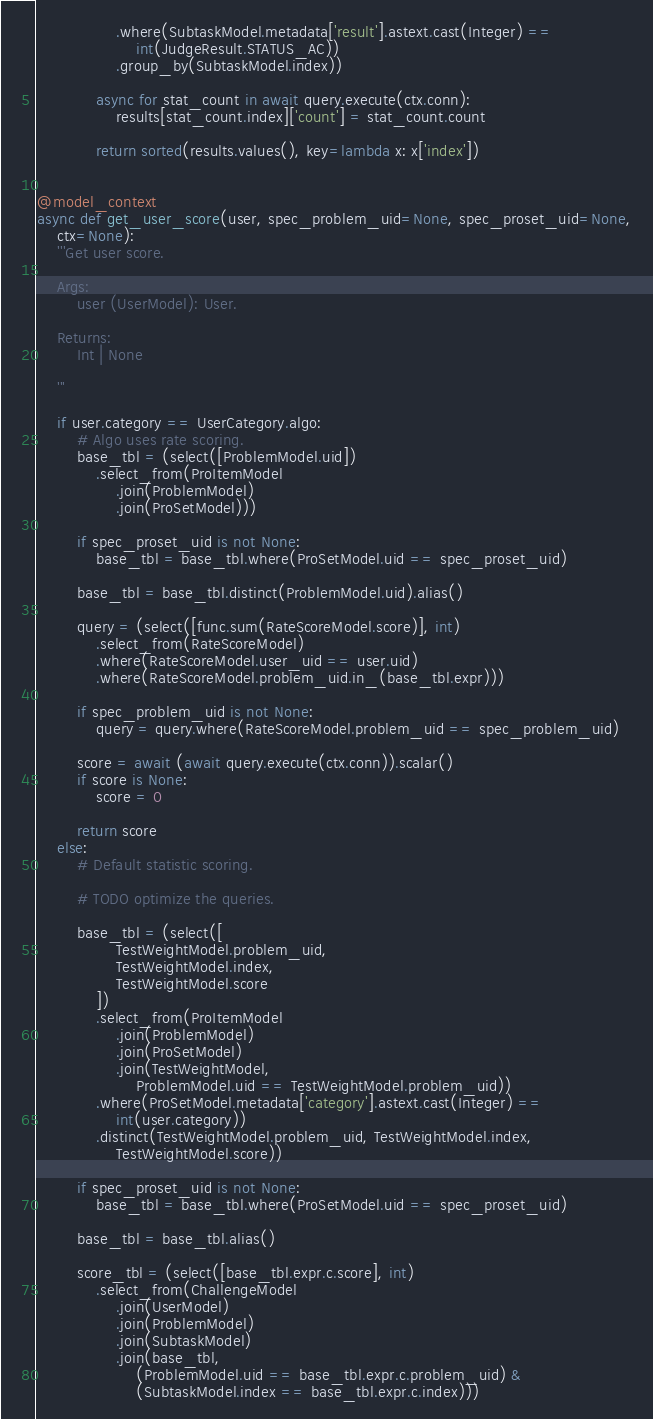Convert code to text. <code><loc_0><loc_0><loc_500><loc_500><_Python_>                .where(SubtaskModel.metadata['result'].astext.cast(Integer) ==
                    int(JudgeResult.STATUS_AC))
                .group_by(SubtaskModel.index))

            async for stat_count in await query.execute(ctx.conn):
                results[stat_count.index]['count'] = stat_count.count

            return sorted(results.values(), key=lambda x: x['index'])


@model_context
async def get_user_score(user, spec_problem_uid=None, spec_proset_uid=None,
    ctx=None):
    '''Get user score.

    Args:
        user (UserModel): User.

    Returns:
        Int | None

    '''

    if user.category == UserCategory.algo:
        # Algo uses rate scoring.
        base_tbl = (select([ProblemModel.uid])
            .select_from(ProItemModel
                .join(ProblemModel)
                .join(ProSetModel)))

        if spec_proset_uid is not None:
            base_tbl = base_tbl.where(ProSetModel.uid == spec_proset_uid)

        base_tbl = base_tbl.distinct(ProblemModel.uid).alias()

        query = (select([func.sum(RateScoreModel.score)], int)
            .select_from(RateScoreModel)
            .where(RateScoreModel.user_uid == user.uid)
            .where(RateScoreModel.problem_uid.in_(base_tbl.expr)))

        if spec_problem_uid is not None:
            query = query.where(RateScoreModel.problem_uid == spec_problem_uid)

        score = await (await query.execute(ctx.conn)).scalar()
        if score is None:
            score = 0

        return score
    else:
        # Default statistic scoring.

        # TODO optimize the queries.

        base_tbl = (select([
                TestWeightModel.problem_uid,
                TestWeightModel.index,
                TestWeightModel.score
            ])
            .select_from(ProItemModel
                .join(ProblemModel)
                .join(ProSetModel)
                .join(TestWeightModel,
                    ProblemModel.uid == TestWeightModel.problem_uid))
            .where(ProSetModel.metadata['category'].astext.cast(Integer) ==
                int(user.category))
            .distinct(TestWeightModel.problem_uid, TestWeightModel.index,
                TestWeightModel.score))

        if spec_proset_uid is not None:
            base_tbl = base_tbl.where(ProSetModel.uid == spec_proset_uid)

        base_tbl = base_tbl.alias()

        score_tbl = (select([base_tbl.expr.c.score], int)
            .select_from(ChallengeModel
                .join(UserModel)
                .join(ProblemModel)
                .join(SubtaskModel)
                .join(base_tbl,
                    (ProblemModel.uid == base_tbl.expr.c.problem_uid) &
                    (SubtaskModel.index == base_tbl.expr.c.index)))</code> 